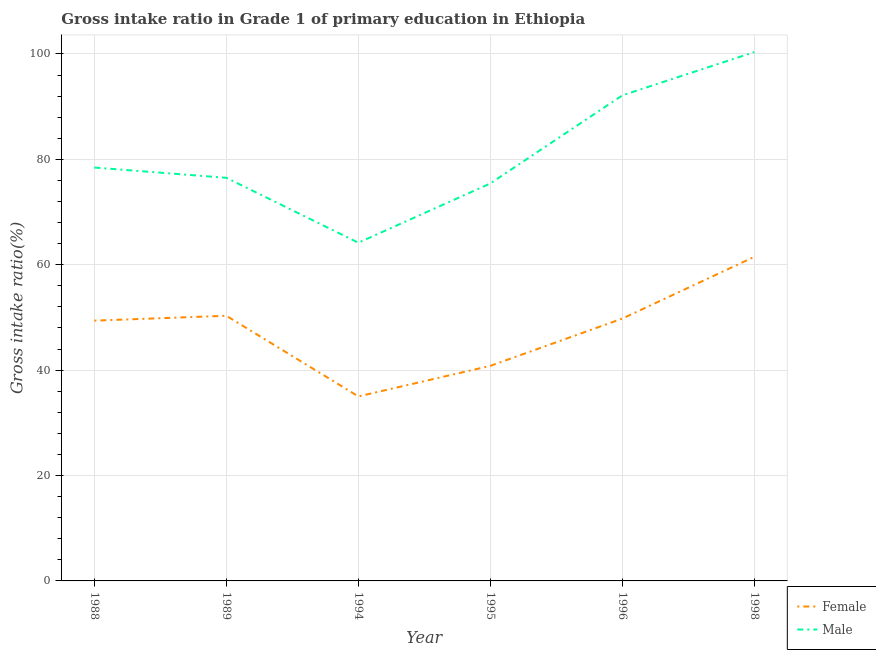What is the gross intake ratio(female) in 1989?
Offer a terse response. 50.32. Across all years, what is the maximum gross intake ratio(male)?
Your answer should be very brief. 100.36. Across all years, what is the minimum gross intake ratio(male)?
Keep it short and to the point. 64.18. What is the total gross intake ratio(male) in the graph?
Offer a terse response. 487.08. What is the difference between the gross intake ratio(female) in 1988 and that in 1994?
Your response must be concise. 14.38. What is the difference between the gross intake ratio(male) in 1994 and the gross intake ratio(female) in 1995?
Offer a terse response. 23.37. What is the average gross intake ratio(male) per year?
Your answer should be compact. 81.18. In the year 1989, what is the difference between the gross intake ratio(male) and gross intake ratio(female)?
Provide a succinct answer. 26.18. What is the ratio of the gross intake ratio(female) in 1994 to that in 1995?
Offer a very short reply. 0.86. What is the difference between the highest and the second highest gross intake ratio(male)?
Your answer should be very brief. 8.21. What is the difference between the highest and the lowest gross intake ratio(male)?
Keep it short and to the point. 36.18. In how many years, is the gross intake ratio(male) greater than the average gross intake ratio(male) taken over all years?
Make the answer very short. 2. Is the sum of the gross intake ratio(female) in 1994 and 1996 greater than the maximum gross intake ratio(male) across all years?
Your response must be concise. No. Does the gross intake ratio(male) monotonically increase over the years?
Offer a very short reply. No. How many years are there in the graph?
Your answer should be compact. 6. What is the difference between two consecutive major ticks on the Y-axis?
Provide a short and direct response. 20. Does the graph contain grids?
Provide a short and direct response. Yes. How many legend labels are there?
Your answer should be very brief. 2. How are the legend labels stacked?
Provide a short and direct response. Vertical. What is the title of the graph?
Keep it short and to the point. Gross intake ratio in Grade 1 of primary education in Ethiopia. Does "GDP per capita" appear as one of the legend labels in the graph?
Provide a short and direct response. No. What is the label or title of the Y-axis?
Offer a very short reply. Gross intake ratio(%). What is the Gross intake ratio(%) of Female in 1988?
Offer a very short reply. 49.39. What is the Gross intake ratio(%) of Male in 1988?
Provide a succinct answer. 78.45. What is the Gross intake ratio(%) in Female in 1989?
Your response must be concise. 50.32. What is the Gross intake ratio(%) of Male in 1989?
Give a very brief answer. 76.5. What is the Gross intake ratio(%) of Female in 1994?
Provide a succinct answer. 35.01. What is the Gross intake ratio(%) in Male in 1994?
Your answer should be very brief. 64.18. What is the Gross intake ratio(%) in Female in 1995?
Keep it short and to the point. 40.81. What is the Gross intake ratio(%) of Male in 1995?
Your answer should be very brief. 75.43. What is the Gross intake ratio(%) of Female in 1996?
Offer a terse response. 49.79. What is the Gross intake ratio(%) in Male in 1996?
Provide a short and direct response. 92.15. What is the Gross intake ratio(%) of Female in 1998?
Keep it short and to the point. 61.51. What is the Gross intake ratio(%) in Male in 1998?
Your answer should be very brief. 100.36. Across all years, what is the maximum Gross intake ratio(%) in Female?
Provide a succinct answer. 61.51. Across all years, what is the maximum Gross intake ratio(%) of Male?
Your answer should be very brief. 100.36. Across all years, what is the minimum Gross intake ratio(%) in Female?
Ensure brevity in your answer.  35.01. Across all years, what is the minimum Gross intake ratio(%) of Male?
Keep it short and to the point. 64.18. What is the total Gross intake ratio(%) of Female in the graph?
Your response must be concise. 286.84. What is the total Gross intake ratio(%) in Male in the graph?
Your answer should be very brief. 487.08. What is the difference between the Gross intake ratio(%) in Female in 1988 and that in 1989?
Offer a terse response. -0.92. What is the difference between the Gross intake ratio(%) of Male in 1988 and that in 1989?
Make the answer very short. 1.95. What is the difference between the Gross intake ratio(%) in Female in 1988 and that in 1994?
Ensure brevity in your answer.  14.38. What is the difference between the Gross intake ratio(%) in Male in 1988 and that in 1994?
Your response must be concise. 14.26. What is the difference between the Gross intake ratio(%) of Female in 1988 and that in 1995?
Offer a very short reply. 8.58. What is the difference between the Gross intake ratio(%) in Male in 1988 and that in 1995?
Your answer should be very brief. 3.01. What is the difference between the Gross intake ratio(%) of Female in 1988 and that in 1996?
Keep it short and to the point. -0.39. What is the difference between the Gross intake ratio(%) in Male in 1988 and that in 1996?
Offer a very short reply. -13.7. What is the difference between the Gross intake ratio(%) in Female in 1988 and that in 1998?
Provide a succinct answer. -12.11. What is the difference between the Gross intake ratio(%) of Male in 1988 and that in 1998?
Make the answer very short. -21.91. What is the difference between the Gross intake ratio(%) of Female in 1989 and that in 1994?
Keep it short and to the point. 15.31. What is the difference between the Gross intake ratio(%) in Male in 1989 and that in 1994?
Your answer should be very brief. 12.32. What is the difference between the Gross intake ratio(%) in Female in 1989 and that in 1995?
Make the answer very short. 9.51. What is the difference between the Gross intake ratio(%) in Male in 1989 and that in 1995?
Make the answer very short. 1.07. What is the difference between the Gross intake ratio(%) in Female in 1989 and that in 1996?
Offer a very short reply. 0.53. What is the difference between the Gross intake ratio(%) of Male in 1989 and that in 1996?
Give a very brief answer. -15.65. What is the difference between the Gross intake ratio(%) of Female in 1989 and that in 1998?
Your answer should be compact. -11.19. What is the difference between the Gross intake ratio(%) of Male in 1989 and that in 1998?
Your answer should be compact. -23.86. What is the difference between the Gross intake ratio(%) of Female in 1994 and that in 1995?
Your response must be concise. -5.8. What is the difference between the Gross intake ratio(%) in Male in 1994 and that in 1995?
Your answer should be very brief. -11.25. What is the difference between the Gross intake ratio(%) in Female in 1994 and that in 1996?
Provide a short and direct response. -14.77. What is the difference between the Gross intake ratio(%) in Male in 1994 and that in 1996?
Offer a very short reply. -27.97. What is the difference between the Gross intake ratio(%) in Female in 1994 and that in 1998?
Offer a terse response. -26.49. What is the difference between the Gross intake ratio(%) in Male in 1994 and that in 1998?
Ensure brevity in your answer.  -36.18. What is the difference between the Gross intake ratio(%) of Female in 1995 and that in 1996?
Keep it short and to the point. -8.97. What is the difference between the Gross intake ratio(%) in Male in 1995 and that in 1996?
Offer a very short reply. -16.71. What is the difference between the Gross intake ratio(%) of Female in 1995 and that in 1998?
Your answer should be very brief. -20.69. What is the difference between the Gross intake ratio(%) in Male in 1995 and that in 1998?
Ensure brevity in your answer.  -24.93. What is the difference between the Gross intake ratio(%) of Female in 1996 and that in 1998?
Offer a very short reply. -11.72. What is the difference between the Gross intake ratio(%) in Male in 1996 and that in 1998?
Provide a short and direct response. -8.21. What is the difference between the Gross intake ratio(%) of Female in 1988 and the Gross intake ratio(%) of Male in 1989?
Ensure brevity in your answer.  -27.11. What is the difference between the Gross intake ratio(%) of Female in 1988 and the Gross intake ratio(%) of Male in 1994?
Offer a terse response. -14.79. What is the difference between the Gross intake ratio(%) in Female in 1988 and the Gross intake ratio(%) in Male in 1995?
Your answer should be compact. -26.04. What is the difference between the Gross intake ratio(%) of Female in 1988 and the Gross intake ratio(%) of Male in 1996?
Your answer should be compact. -42.75. What is the difference between the Gross intake ratio(%) of Female in 1988 and the Gross intake ratio(%) of Male in 1998?
Your answer should be very brief. -50.96. What is the difference between the Gross intake ratio(%) in Female in 1989 and the Gross intake ratio(%) in Male in 1994?
Your response must be concise. -13.87. What is the difference between the Gross intake ratio(%) in Female in 1989 and the Gross intake ratio(%) in Male in 1995?
Provide a short and direct response. -25.12. What is the difference between the Gross intake ratio(%) of Female in 1989 and the Gross intake ratio(%) of Male in 1996?
Give a very brief answer. -41.83. What is the difference between the Gross intake ratio(%) in Female in 1989 and the Gross intake ratio(%) in Male in 1998?
Provide a succinct answer. -50.04. What is the difference between the Gross intake ratio(%) of Female in 1994 and the Gross intake ratio(%) of Male in 1995?
Your answer should be very brief. -40.42. What is the difference between the Gross intake ratio(%) of Female in 1994 and the Gross intake ratio(%) of Male in 1996?
Give a very brief answer. -57.14. What is the difference between the Gross intake ratio(%) of Female in 1994 and the Gross intake ratio(%) of Male in 1998?
Offer a terse response. -65.35. What is the difference between the Gross intake ratio(%) in Female in 1995 and the Gross intake ratio(%) in Male in 1996?
Offer a very short reply. -51.34. What is the difference between the Gross intake ratio(%) of Female in 1995 and the Gross intake ratio(%) of Male in 1998?
Make the answer very short. -59.55. What is the difference between the Gross intake ratio(%) of Female in 1996 and the Gross intake ratio(%) of Male in 1998?
Provide a short and direct response. -50.57. What is the average Gross intake ratio(%) of Female per year?
Give a very brief answer. 47.81. What is the average Gross intake ratio(%) of Male per year?
Give a very brief answer. 81.18. In the year 1988, what is the difference between the Gross intake ratio(%) of Female and Gross intake ratio(%) of Male?
Offer a very short reply. -29.05. In the year 1989, what is the difference between the Gross intake ratio(%) in Female and Gross intake ratio(%) in Male?
Provide a succinct answer. -26.18. In the year 1994, what is the difference between the Gross intake ratio(%) of Female and Gross intake ratio(%) of Male?
Offer a terse response. -29.17. In the year 1995, what is the difference between the Gross intake ratio(%) of Female and Gross intake ratio(%) of Male?
Provide a succinct answer. -34.62. In the year 1996, what is the difference between the Gross intake ratio(%) of Female and Gross intake ratio(%) of Male?
Your answer should be compact. -42.36. In the year 1998, what is the difference between the Gross intake ratio(%) of Female and Gross intake ratio(%) of Male?
Your response must be concise. -38.85. What is the ratio of the Gross intake ratio(%) in Female in 1988 to that in 1989?
Give a very brief answer. 0.98. What is the ratio of the Gross intake ratio(%) in Male in 1988 to that in 1989?
Give a very brief answer. 1.03. What is the ratio of the Gross intake ratio(%) in Female in 1988 to that in 1994?
Offer a very short reply. 1.41. What is the ratio of the Gross intake ratio(%) of Male in 1988 to that in 1994?
Ensure brevity in your answer.  1.22. What is the ratio of the Gross intake ratio(%) in Female in 1988 to that in 1995?
Make the answer very short. 1.21. What is the ratio of the Gross intake ratio(%) in Female in 1988 to that in 1996?
Provide a short and direct response. 0.99. What is the ratio of the Gross intake ratio(%) in Male in 1988 to that in 1996?
Keep it short and to the point. 0.85. What is the ratio of the Gross intake ratio(%) of Female in 1988 to that in 1998?
Provide a succinct answer. 0.8. What is the ratio of the Gross intake ratio(%) in Male in 1988 to that in 1998?
Offer a very short reply. 0.78. What is the ratio of the Gross intake ratio(%) of Female in 1989 to that in 1994?
Provide a succinct answer. 1.44. What is the ratio of the Gross intake ratio(%) of Male in 1989 to that in 1994?
Give a very brief answer. 1.19. What is the ratio of the Gross intake ratio(%) in Female in 1989 to that in 1995?
Keep it short and to the point. 1.23. What is the ratio of the Gross intake ratio(%) of Male in 1989 to that in 1995?
Your response must be concise. 1.01. What is the ratio of the Gross intake ratio(%) in Female in 1989 to that in 1996?
Your response must be concise. 1.01. What is the ratio of the Gross intake ratio(%) in Male in 1989 to that in 1996?
Provide a short and direct response. 0.83. What is the ratio of the Gross intake ratio(%) of Female in 1989 to that in 1998?
Give a very brief answer. 0.82. What is the ratio of the Gross intake ratio(%) in Male in 1989 to that in 1998?
Provide a short and direct response. 0.76. What is the ratio of the Gross intake ratio(%) in Female in 1994 to that in 1995?
Provide a short and direct response. 0.86. What is the ratio of the Gross intake ratio(%) in Male in 1994 to that in 1995?
Make the answer very short. 0.85. What is the ratio of the Gross intake ratio(%) of Female in 1994 to that in 1996?
Give a very brief answer. 0.7. What is the ratio of the Gross intake ratio(%) of Male in 1994 to that in 1996?
Provide a short and direct response. 0.7. What is the ratio of the Gross intake ratio(%) of Female in 1994 to that in 1998?
Give a very brief answer. 0.57. What is the ratio of the Gross intake ratio(%) in Male in 1994 to that in 1998?
Your response must be concise. 0.64. What is the ratio of the Gross intake ratio(%) in Female in 1995 to that in 1996?
Your response must be concise. 0.82. What is the ratio of the Gross intake ratio(%) in Male in 1995 to that in 1996?
Keep it short and to the point. 0.82. What is the ratio of the Gross intake ratio(%) of Female in 1995 to that in 1998?
Ensure brevity in your answer.  0.66. What is the ratio of the Gross intake ratio(%) in Male in 1995 to that in 1998?
Provide a succinct answer. 0.75. What is the ratio of the Gross intake ratio(%) of Female in 1996 to that in 1998?
Offer a very short reply. 0.81. What is the ratio of the Gross intake ratio(%) in Male in 1996 to that in 1998?
Make the answer very short. 0.92. What is the difference between the highest and the second highest Gross intake ratio(%) in Female?
Your answer should be very brief. 11.19. What is the difference between the highest and the second highest Gross intake ratio(%) of Male?
Keep it short and to the point. 8.21. What is the difference between the highest and the lowest Gross intake ratio(%) in Female?
Your answer should be compact. 26.49. What is the difference between the highest and the lowest Gross intake ratio(%) in Male?
Offer a very short reply. 36.18. 